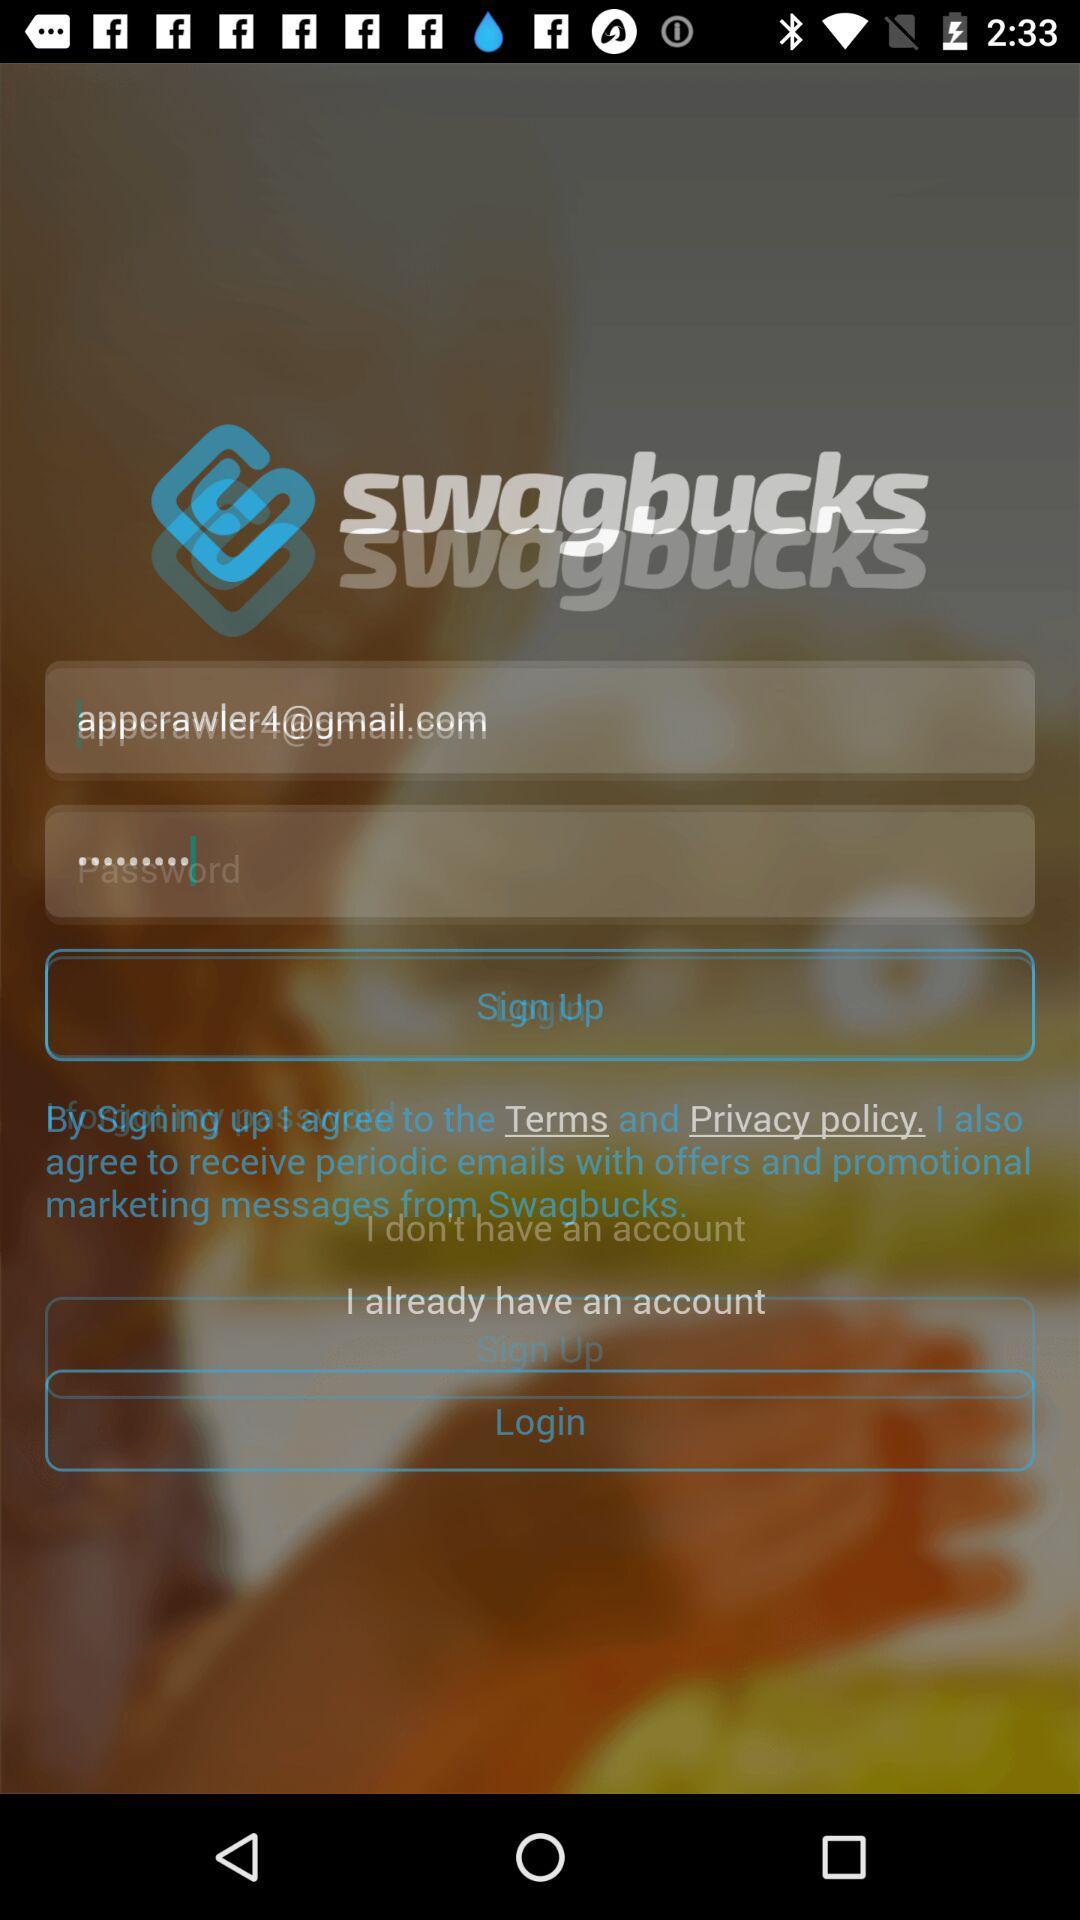How many characters are required to create a password?
When the provided information is insufficient, respond with <no answer>. <no answer> 